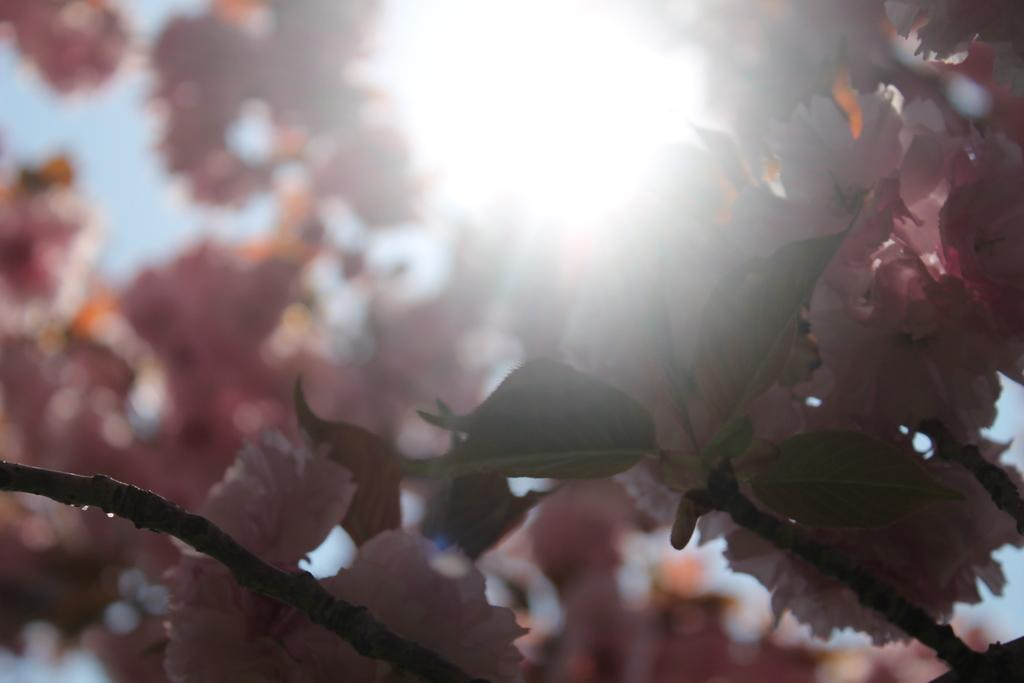What type of vegetation can be seen on the tree in the image? There are flowers on a tree in the image. What natural light source is visible in the image? Sunlight is visible in the image. What type of verse can be heard recited by the pigs in the image? There are no pigs present in the image, and therefore no verses can be heard. 